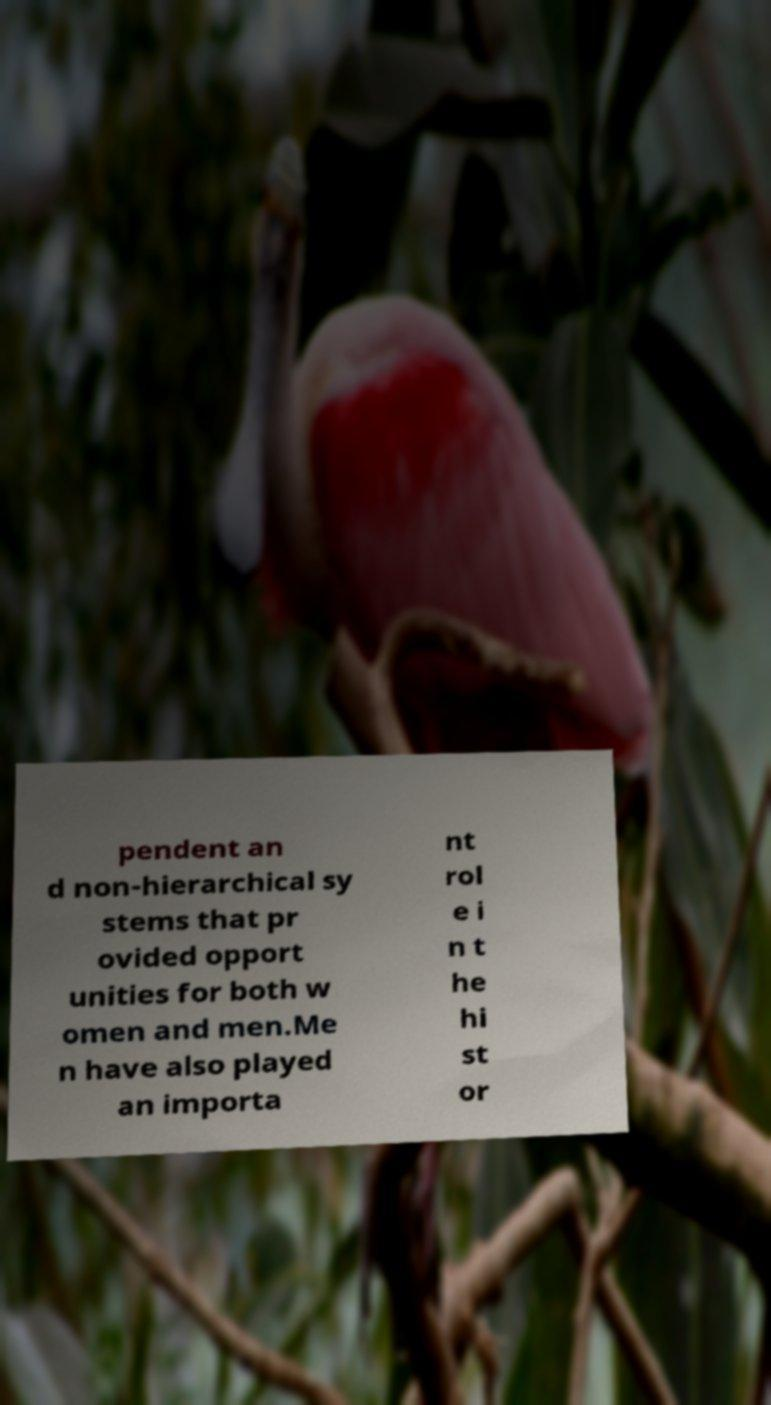Can you read and provide the text displayed in the image?This photo seems to have some interesting text. Can you extract and type it out for me? pendent an d non-hierarchical sy stems that pr ovided opport unities for both w omen and men.Me n have also played an importa nt rol e i n t he hi st or 